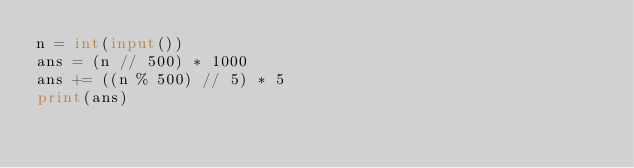<code> <loc_0><loc_0><loc_500><loc_500><_Python_>n = int(input())
ans = (n // 500) * 1000
ans += ((n % 500) // 5) * 5
print(ans)
</code> 